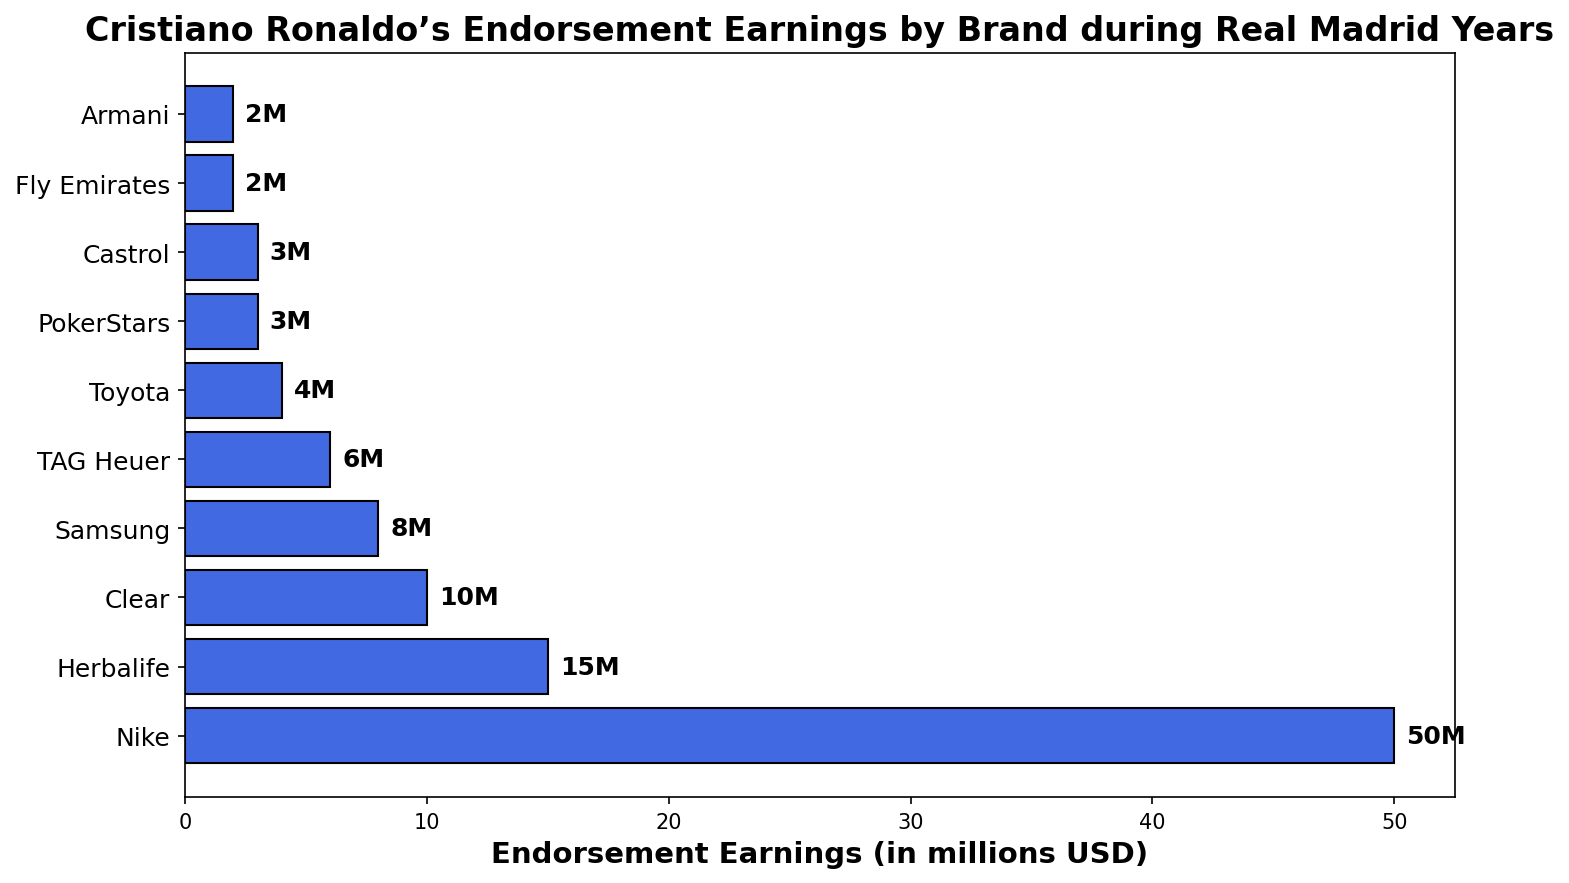Which brand gave Cristiano Ronaldo the highest endorsement earnings during his Real Madrid years? The bar chart shows the endorsement earnings for various brands, with Nike having the longest bar, indicating the highest earnings.
Answer: Nike Which brand gave him the least endorsement earnings? The bar chart shows that Armani and Fly Emirates have the shortest bars, indicating the lowest earnings.
Answer: Armani and Fly Emirates How much more did Cristiano Ronaldo earn from Nike compared to Samsung? To find out, look at the bar lengths for Nike and Samsung. Nike is at 50 million USD, and Samsung is at 8 million USD. Calculate the difference: 50 - 8 = 42 million USD.
Answer: 42 million USD What is the total endorsement earnings from Clear, TAG Heuer, and Toyota combined? Add the values from the bars of Clear (10 million USD), TAG Heuer (6 million USD), and Toyota (4 million USD): 10 + 6 + 4 = 20 million USD.
Answer: 20 million USD Is the average endorsement earnings from the top three brands (Nike, Herbalife, and Clear) more or less than 25 million USD? First, add the earnings from the top three brands: Nike (50 million USD), Herbalife (15 million USD), and Clear (10 million USD): 50 + 15 + 10 = 75 million USD. Then, calculate the average by dividing by 3: 75 / 3 = 25 million USD. Since the average is exactly 25 million USD, the answer is neither more nor less.
Answer: Equals 25 million USD How do the combined earnings from PokerStars and Castrol compare to the earnings from TAG Heuer? Add the earnings from PokerStars and Castrol: 3 + 3 = 6 million USD. TAG Heuer has 6 million USD. Therefore, the earnings are equal.
Answer: Equal Which brand between Herbalife and Toyota had a higher endorsement earning, and by how much? Compare the bar lengths of Herbalife (15 million USD) and Toyota (4 million USD). The difference is 15 - 4 = 11 million USD.
Answer: Herbalife by 11 million USD What is the difference in endorsement earnings between the highest and the lowest earning brands? The highest earning brand is Nike (50 million USD) and the lowest earning brands are Armani and Fly Emirates (2 million USD). The difference is 50 - 2 = 48 million USD.
Answer: 48 million USD What is the total endorsement earnings from all brands combined? Add up all the earnings: 50 + 15 + 10 + 8 + 6 + 4 + 3 + 3 + 2 + 2 = 103 million USD.
Answer: 103 million USD Among the listed brands, how many generated less than 5 million USD in endorsement earnings for Cristiano Ronaldo? Identify the brands with earnings less than 5 million USD: Toyota (4 million USD), PokerStars (3 million USD), Castrol (3 million USD), Fly Emirates (2 million USD), and Armani (2 million USD). Count them, there are 5 such brands.
Answer: 5 brands 